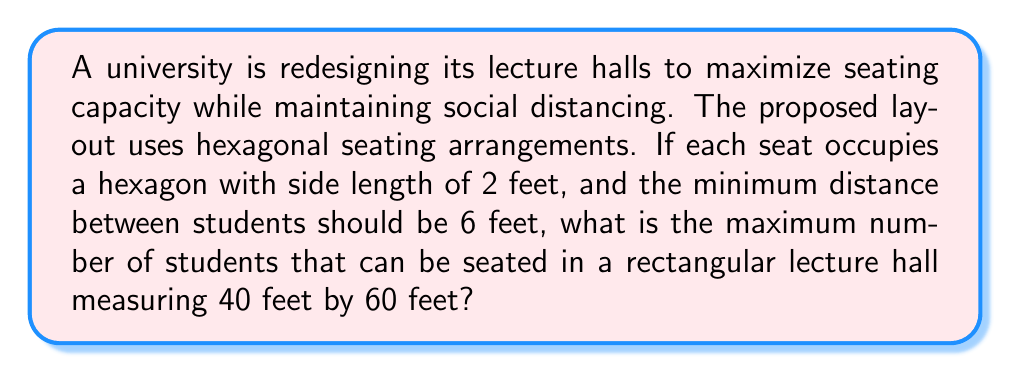Can you solve this math problem? Let's approach this step-by-step:

1) First, we need to determine the size of each hexagonal unit, including the social distancing space:
   - The hexagon side length is 2 feet
   - The minimum distance between students is 6 feet
   - So, we need to add 3 feet to each side of the hexagon (half of 6 feet on each side)
   - The effective side length of each hexagonal unit is thus 5 feet

2) Now, let's calculate the area of this larger hexagon:
   - Area of a regular hexagon = $\frac{3\sqrt{3}}{2}a^2$, where $a$ is the side length
   - Area = $\frac{3\sqrt{3}}{2}(5^2) = \frac{75\sqrt{3}}{2} \approx 64.95$ square feet

3) To arrange these hexagons efficiently, we can use a hexagonal grid pattern. In this pattern, the centers of the hexagons form equilateral triangles.

4) The area of the lecture hall:
   - 40 feet × 60 feet = 2400 square feet

5) To estimate how many hexagons can fit, divide the room area by the hexagon area:
   - $2400 \div (\frac{75\sqrt{3}}{2}) \approx 36.95$

6) However, this is an overestimate because there will be some unused space near the edges of the rectangular room. A more realistic estimate would be about 90% of this number:
   - $36.95 \times 0.9 \approx 33.25$

7) Rounding down to the nearest whole number (as we can't have partial seats), we get 33 seats.

[asy]
unitsize(1cm);
import geometry;

void drawHexagon(pair center, real radius) {
  for (int i = 0; i < 6; ++i) {
    draw(center + radius * dir(60 * i) -- center + radius * dir(60 * (i + 1)));
  }
}

for (int i = 0; i < 6; ++i) {
  for (int j = 0; j < 6; ++j) {
    pair center = (i * sqrt(3) + (j % 2) * (sqrt(3)/2), j * 1.5);
    drawHexagon(center, 0.5);
  }
}

draw((-0.5,-0.5)--(6*sqrt(3)+0.5,-0.5)--(6*sqrt(3)+0.5,7.5)--(-0.5,7.5)--cycle, red);
label("Lecture Hall (not to scale)", (3*sqrt(3),8), N);
[/asy]
Answer: 33 students 